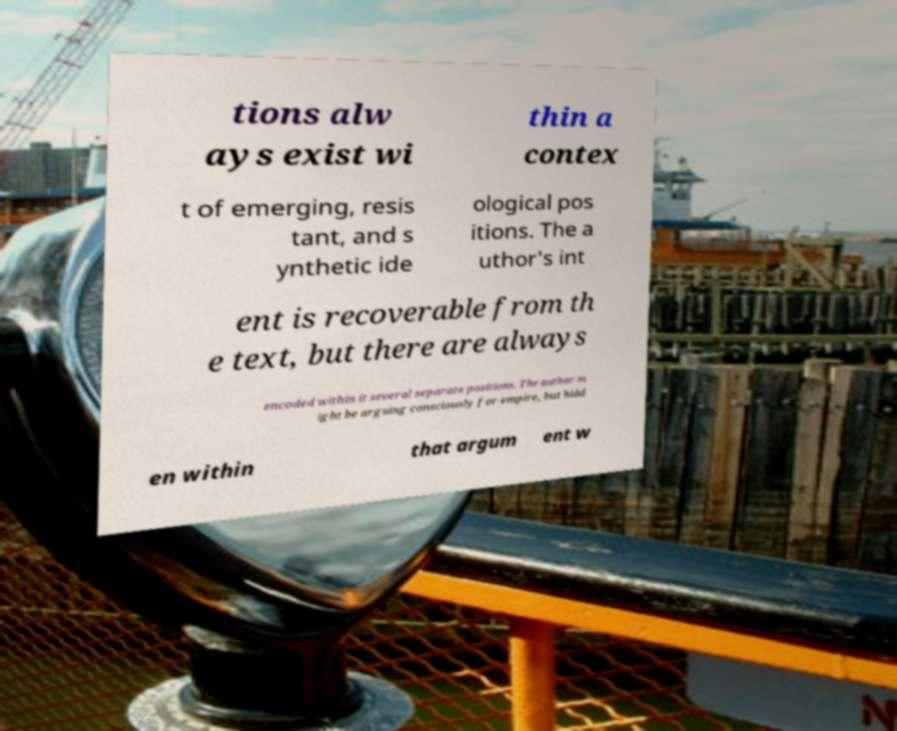Can you read and provide the text displayed in the image?This photo seems to have some interesting text. Can you extract and type it out for me? tions alw ays exist wi thin a contex t of emerging, resis tant, and s ynthetic ide ological pos itions. The a uthor's int ent is recoverable from th e text, but there are always encoded within it several separate positions. The author m ight be arguing consciously for empire, but hidd en within that argum ent w 